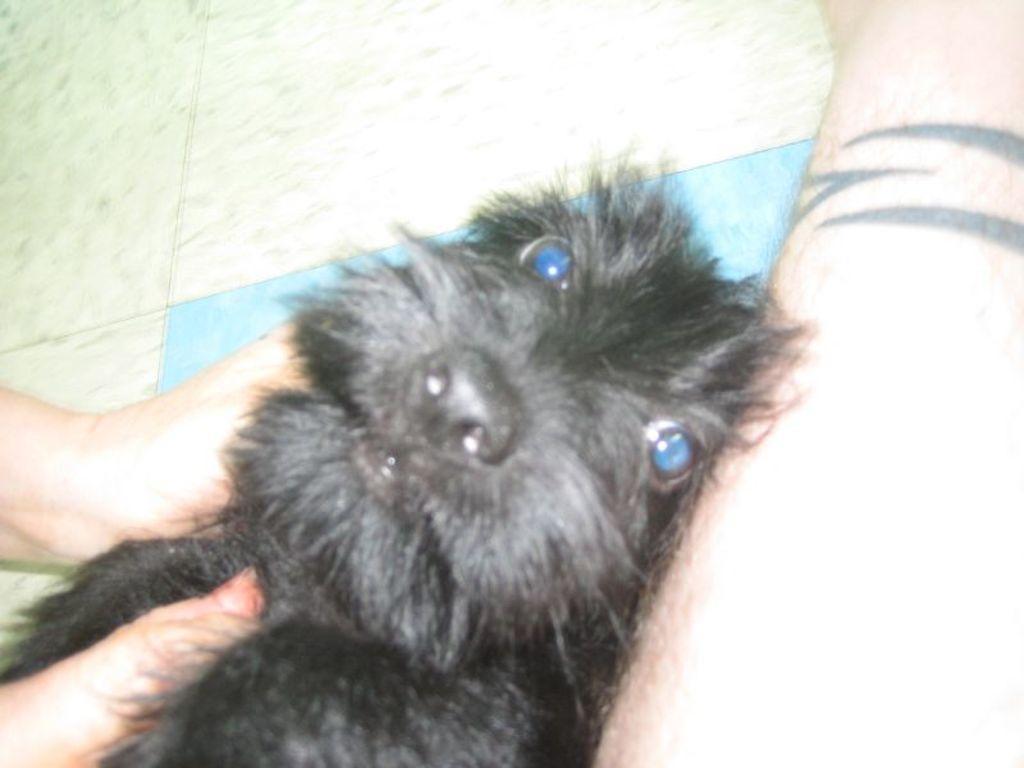Please provide a concise description of this image. In this image we can see the hands and leg of a person, there is a dog on the floor. 